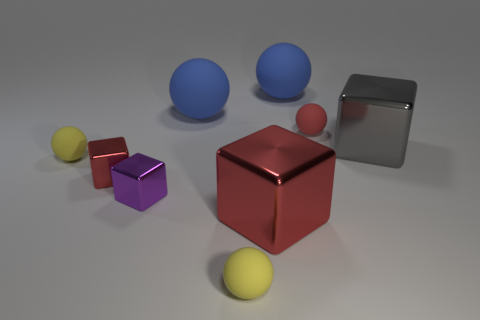Subtract all yellow cubes. How many blue spheres are left? 2 Subtract all tiny red blocks. How many blocks are left? 3 Subtract 3 blocks. How many blocks are left? 1 Subtract all yellow spheres. How many spheres are left? 3 Subtract all spheres. How many objects are left? 4 Subtract all green blocks. Subtract all gray balls. How many blocks are left? 4 Subtract all red rubber objects. Subtract all blue matte balls. How many objects are left? 6 Add 6 tiny yellow balls. How many tiny yellow balls are left? 8 Add 6 large gray shiny blocks. How many large gray shiny blocks exist? 7 Subtract 0 green cylinders. How many objects are left? 9 